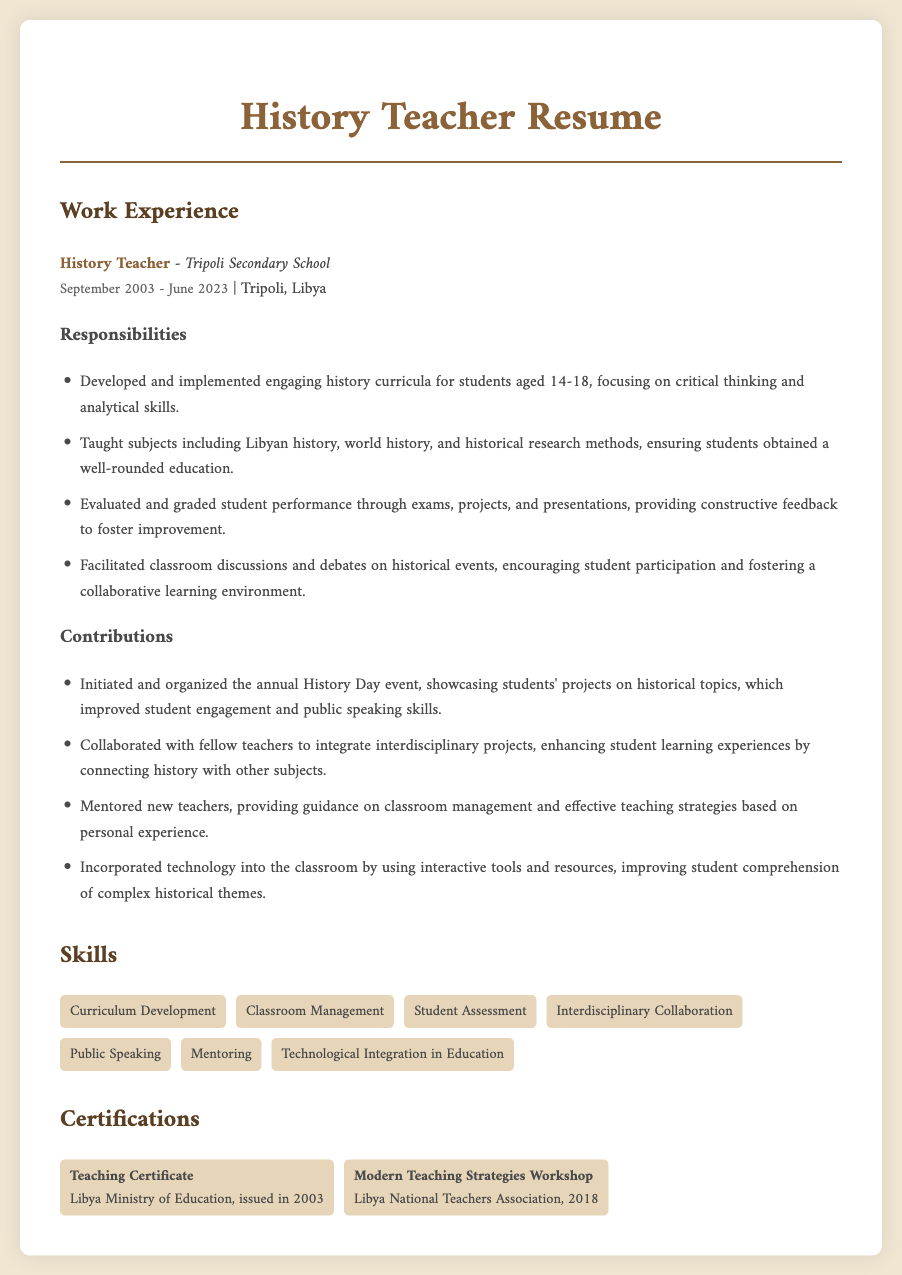What was the job title held from September 2003 to June 2023? The job title is listed in the work experience section of the document.
Answer: History Teacher Which school did the history teacher work at? The name of the institution where the history teacher was employed is mentioned in the work experience section.
Answer: Tripoli Secondary School How many years did the history teacher work at Tripoli Secondary School? To find this, count the years mentioned in the dates section of the document.
Answer: 20 years What key skill involves evaluating student performance? The list of skills includes various areas of expertise, among which relates to judging student work.
Answer: Student Assessment What event did the history teacher initiate to improve student engagement? The contribution section details a specific event organized by the teacher aimed at enhancing student involvement.
Answer: History Day In what year was the Teaching Certificate issued? The issue year of the certificate is provided in the certifications section of the resume.
Answer: 2003 Which organization conducted the Modern Teaching Strategies Workshop? The name of the organization that hosted the workshop is mentioned in the certifications section.
Answer: Libya National Teachers Association What subject was taught alongside world history? The responsibilities section specifies multiple subjects taught by the history teacher, one of which is queried here.
Answer: Libyan history How did the history teacher incorporate technology into the classroom? A point related to classroom enhancements through tech use is explained in the contributions section.
Answer: Improved student comprehension 